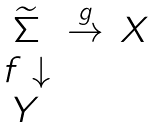Convert formula to latex. <formula><loc_0><loc_0><loc_500><loc_500>\begin{matrix} & \widetilde { \Sigma } & \stackrel { g } { \rightarrow } & X \\ & f \downarrow & & \\ & Y & & \end{matrix}</formula> 